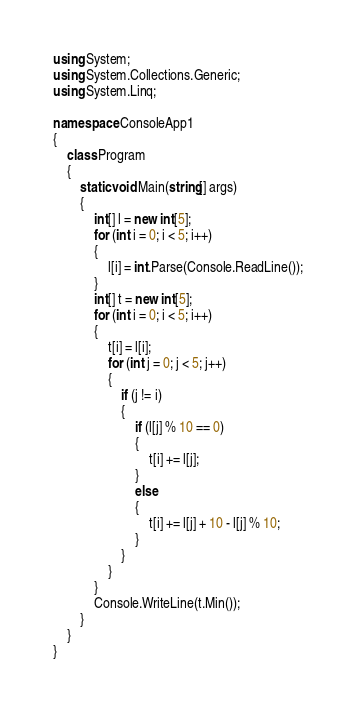<code> <loc_0><loc_0><loc_500><loc_500><_C#_>using System;
using System.Collections.Generic;
using System.Linq;

namespace ConsoleApp1
{
    class Program
    {
        static void Main(string[] args)
        {
            int[] l = new int[5];
            for (int i = 0; i < 5; i++)
            {
                l[i] = int.Parse(Console.ReadLine());
            }
            int[] t = new int[5];
            for (int i = 0; i < 5; i++)
            {
                t[i] = l[i];
                for (int j = 0; j < 5; j++)
                {
                    if (j != i)
                    {
                        if (l[j] % 10 == 0)
                        {
                            t[i] += l[j];
                        }
                        else
                        {
                            t[i] += l[j] + 10 - l[j] % 10;
                        }
                    }
                }
            }
            Console.WriteLine(t.Min());
        }
    }
}</code> 